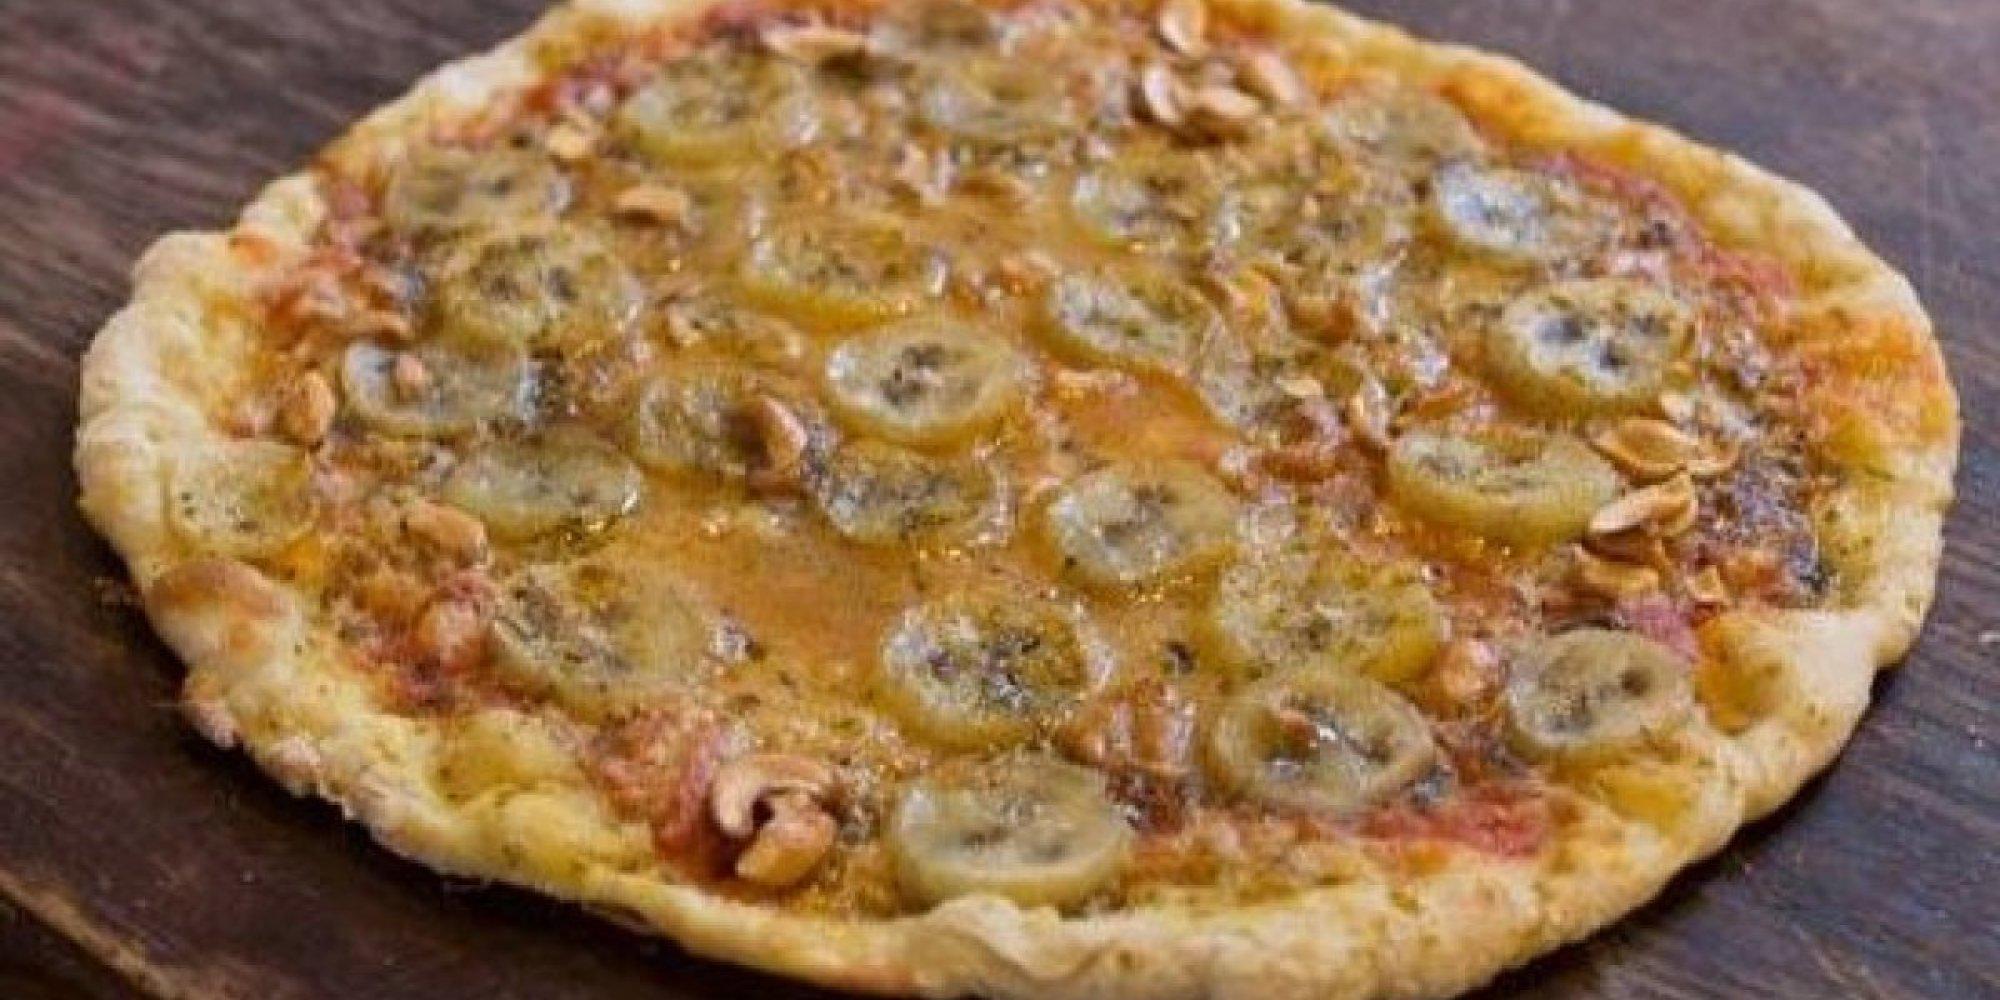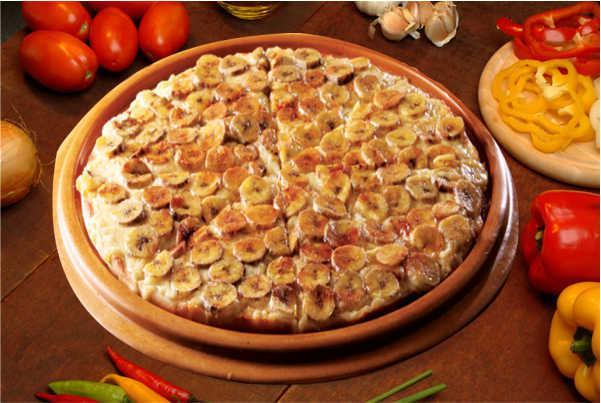The first image is the image on the left, the second image is the image on the right. Considering the images on both sides, is "One image shows a pizza served on a white platter." valid? Answer yes or no. No. 